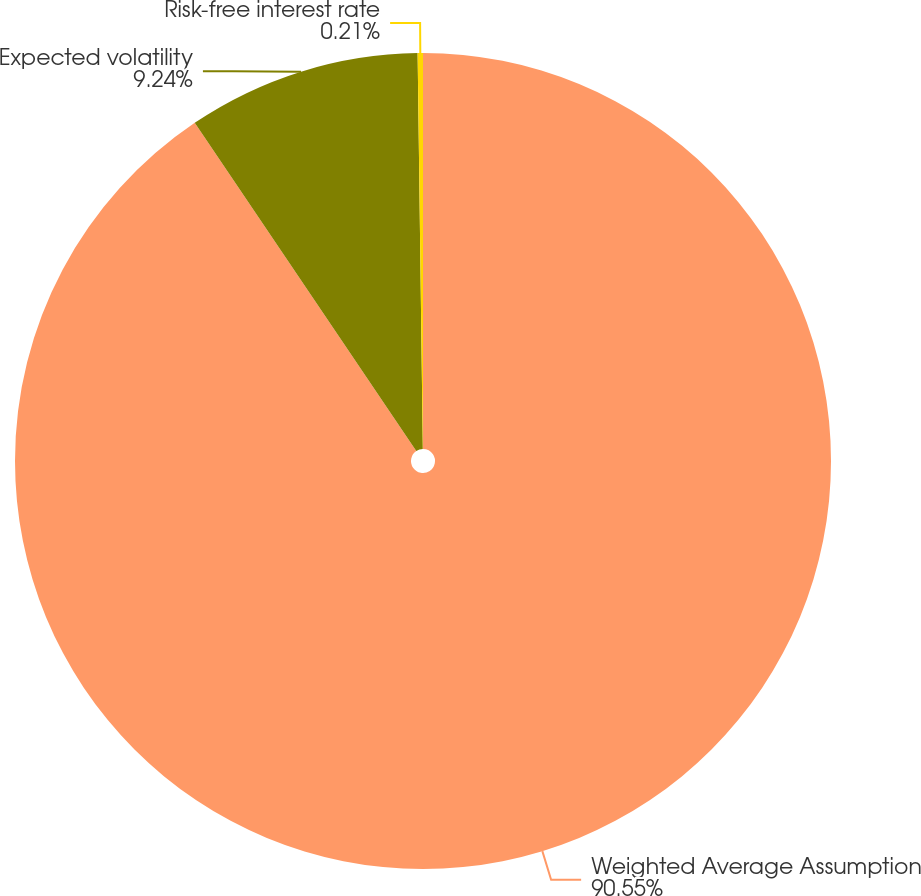Convert chart. <chart><loc_0><loc_0><loc_500><loc_500><pie_chart><fcel>Weighted Average Assumption<fcel>Expected volatility<fcel>Risk-free interest rate<nl><fcel>90.55%<fcel>9.24%<fcel>0.21%<nl></chart> 